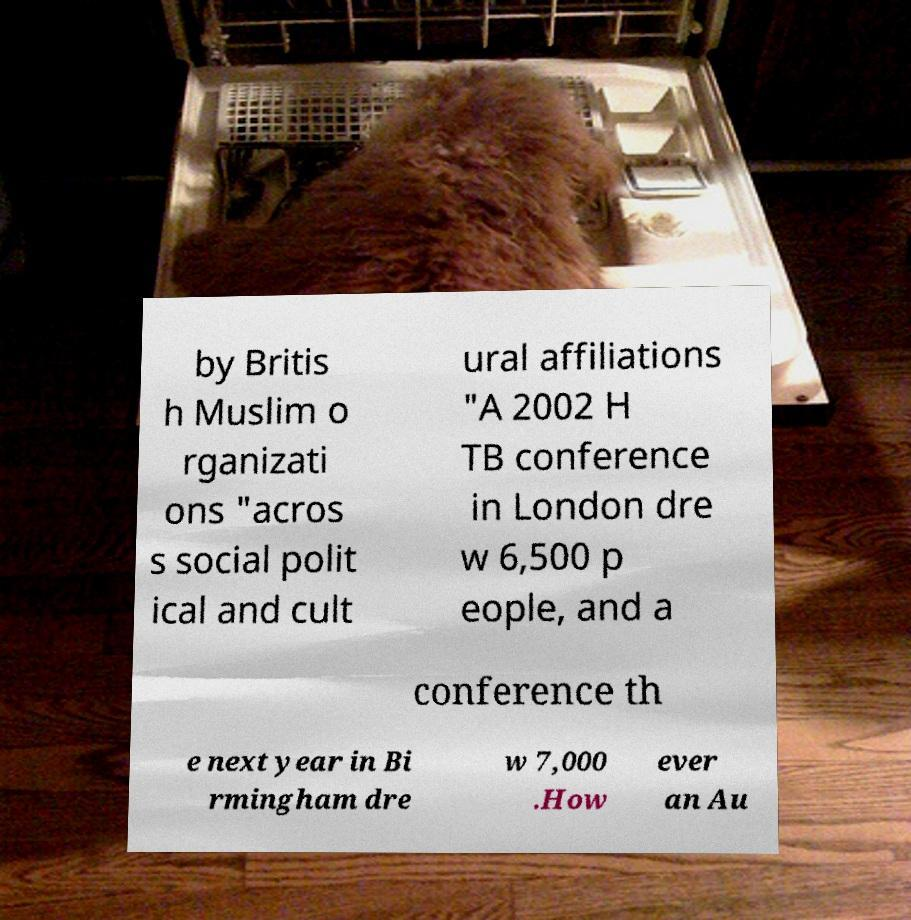What messages or text are displayed in this image? I need them in a readable, typed format. by Britis h Muslim o rganizati ons "acros s social polit ical and cult ural affiliations "A 2002 H TB conference in London dre w 6,500 p eople, and a conference th e next year in Bi rmingham dre w 7,000 .How ever an Au 